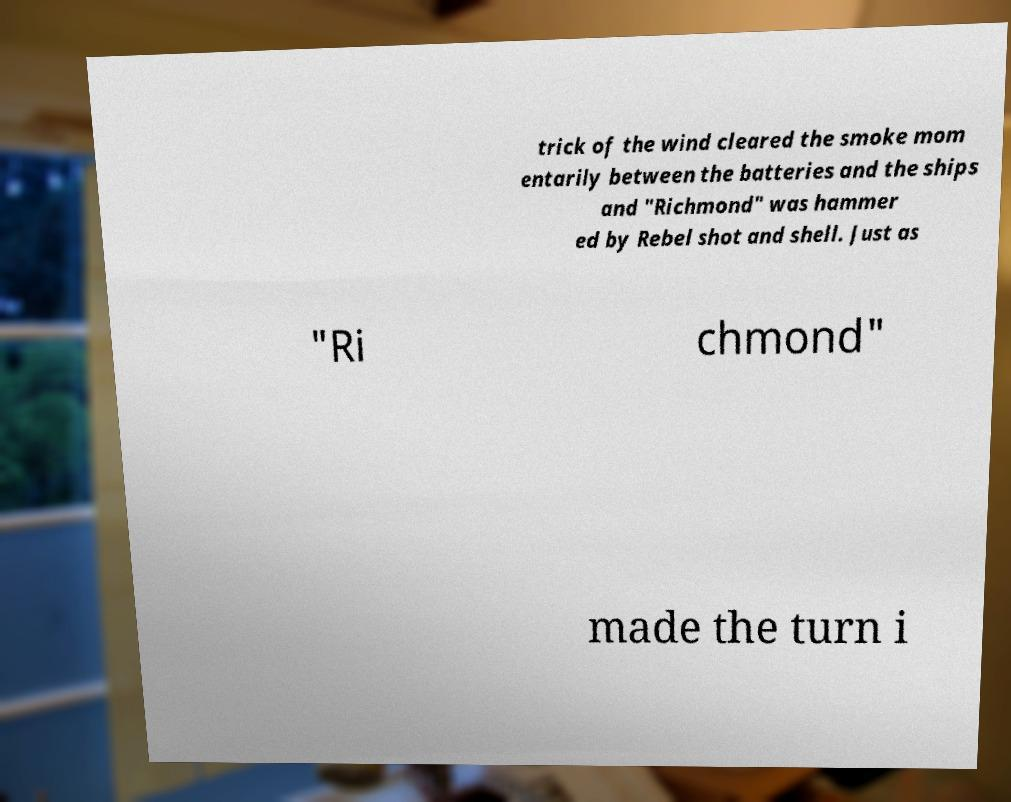There's text embedded in this image that I need extracted. Can you transcribe it verbatim? trick of the wind cleared the smoke mom entarily between the batteries and the ships and "Richmond" was hammer ed by Rebel shot and shell. Just as "Ri chmond" made the turn i 